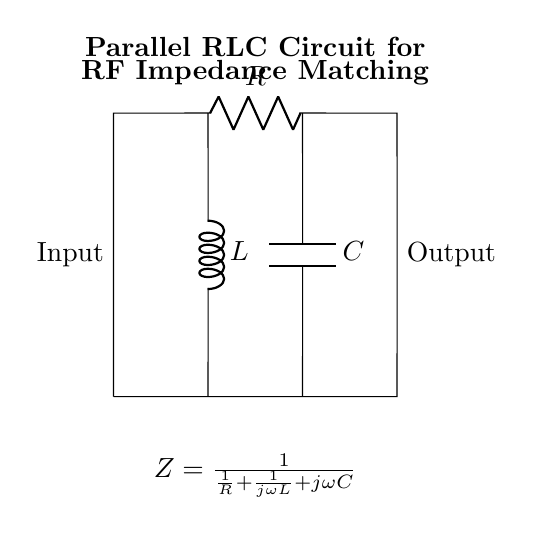What are the components in this circuit? The components in this circuit are a resistor (R), an inductor (L), and a capacitor (C). The diagram clearly labels each component, helping to identify them easily.
Answer: Resistor, Inductor, Capacitor What is the purpose of this circuit? The purpose of this circuit is for RF impedance matching, which is indicated by the title above the components in the diagram. This means it is designed to optimize power transfer in radio frequency applications.
Answer: RF impedance matching What is the formula for impedance shown in the circuit? The formula for impedance presented in the circuit is \( Z = \frac{1}{\frac{1}{R} + \frac{1}{j\omega L} + j\omega C} \). This mathematical expression represents the total impedance of the parallel combination of R, L, and C.
Answer: Z = 1/(1/R + 1/jωL + jωC) If the frequency is increased, how does it affect the circuit impedance? Increasing the frequency (ω) causes the imaginary part of the impedance to change. Specifically, the inductive reactance increases while the capacitive reactance decreases, altering the overall impedance. This means the total circuit impedance is frequency-dependent.
Answer: It decreases What is the relationship between resistance and reactance in this circuit? The relationship is that the impedance of the circuit is a combination of resistive (R) and reactive (L and C) components. The impedance not only depends on resistance but also on the values of the inductance and capacitance, which influence the total reactance.
Answer: Impedance combines resistance and reactance What happens to the circuit if R is increased? Increasing R will generally increase the overall impedance Z of the circuit because more resistance decreases the contribution of the resistive part of the impedance equation. This leads to less current flow for a given voltage.
Answer: Impedance increases What effect does adding capacitance have on the circuit behavior? Adding capacitance will decrease the overall impedance of the circuit since capacitive reactance \((j\omega C)\) is inversely proportional to frequency and capacitance. This can improve current flow at certain frequencies.
Answer: Decreases impedance 